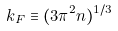<formula> <loc_0><loc_0><loc_500><loc_500>k _ { F } \equiv ( 3 \pi ^ { 2 } n ) ^ { 1 / 3 }</formula> 